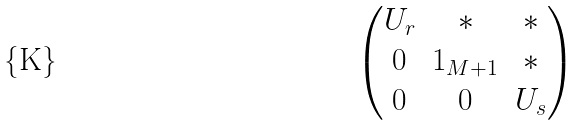<formula> <loc_0><loc_0><loc_500><loc_500>\begin{pmatrix} U _ { r } & { * } & { * } \\ 0 & 1 _ { M + 1 } & { * } \\ 0 & 0 & U _ { s } \end{pmatrix}</formula> 